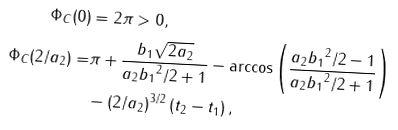Convert formula to latex. <formula><loc_0><loc_0><loc_500><loc_500>\Phi _ { C } ( 0 ) & = 2 \pi > 0 , \\ \Phi _ { C } ( 2 / a _ { 2 } ) = & \pi + \frac { b _ { 1 } \sqrt { 2 a _ { 2 } } } { a _ { 2 } { b _ { 1 } } ^ { 2 } / 2 + 1 } - \arccos \left ( \frac { a _ { 2 } { b _ { 1 } } ^ { 2 } / 2 - 1 } { a _ { 2 } { b _ { 1 } } ^ { 2 } / 2 + 1 } \right ) \\ & - \left ( 2 / a _ { 2 } \right ) ^ { 3 / 2 } \left ( t _ { 2 } - t _ { 1 } \right ) ,</formula> 